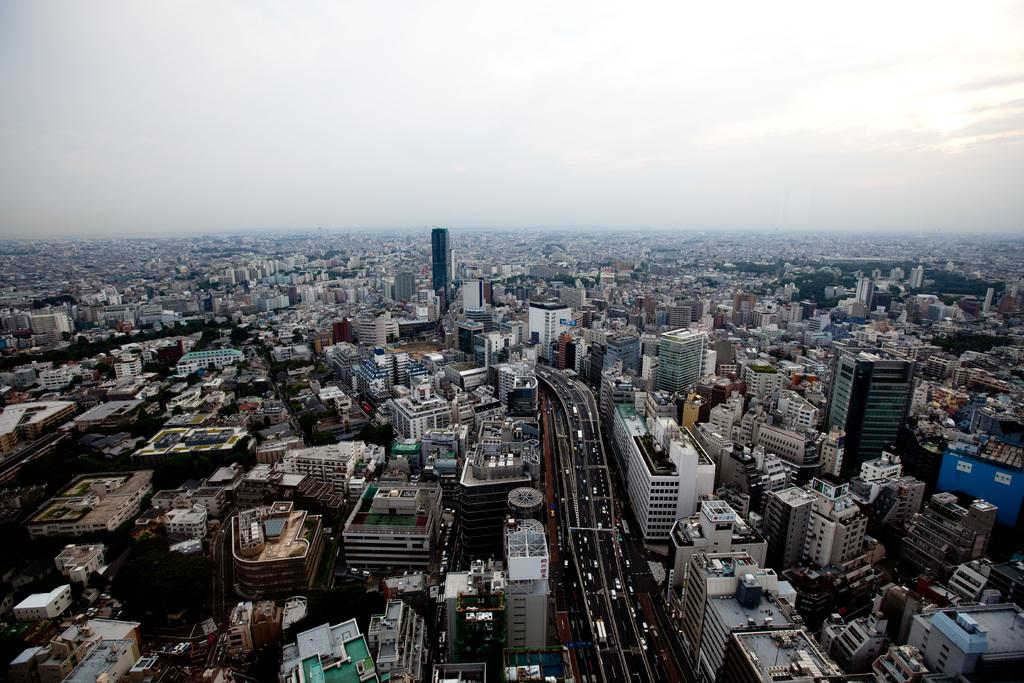What type of structures can be seen in the image? There are many buildings in the image. What else is present in the image besides buildings? There are roads and vehicles in the image. What is visible at the top of the image? The sky is visible at the top of the image. Can you see a tramp performing tricks on the road in the image? No, there is no tramp performing tricks on the road in the image. 